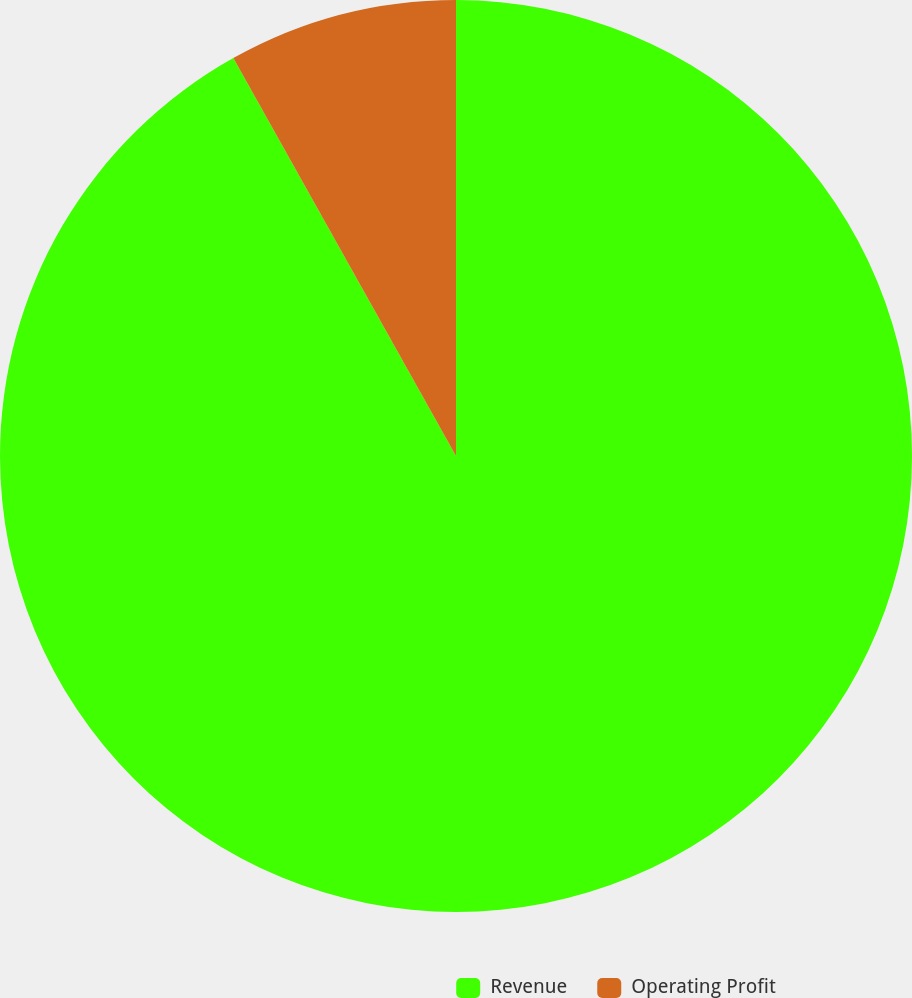Convert chart to OTSL. <chart><loc_0><loc_0><loc_500><loc_500><pie_chart><fcel>Revenue<fcel>Operating Profit<nl><fcel>91.88%<fcel>8.12%<nl></chart> 